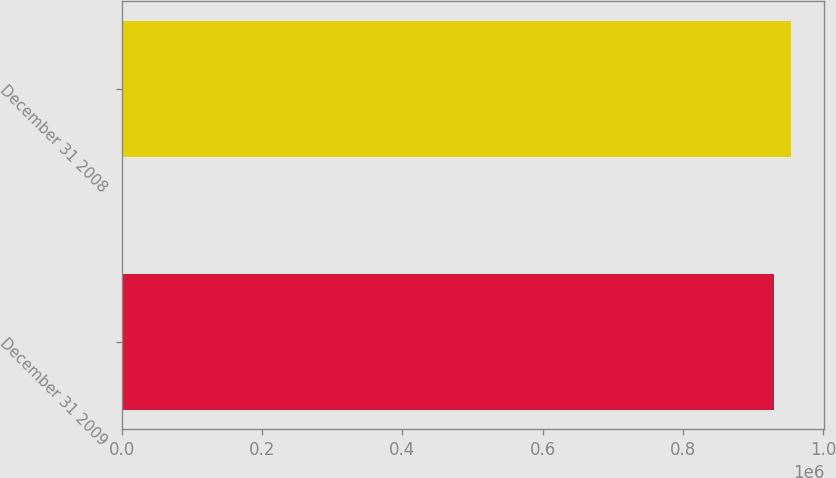Convert chart. <chart><loc_0><loc_0><loc_500><loc_500><bar_chart><fcel>December 31 2009<fcel>December 31 2008<nl><fcel>930239<fcel>954096<nl></chart> 